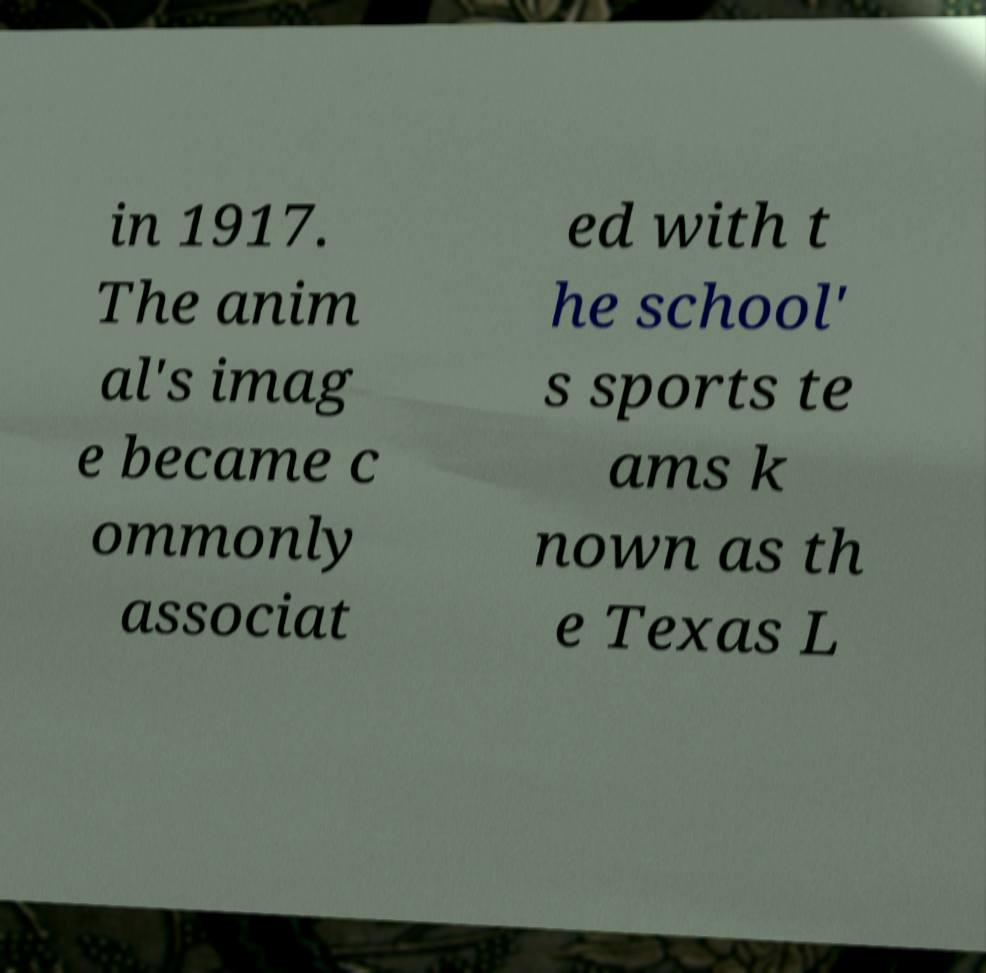I need the written content from this picture converted into text. Can you do that? in 1917. The anim al's imag e became c ommonly associat ed with t he school' s sports te ams k nown as th e Texas L 